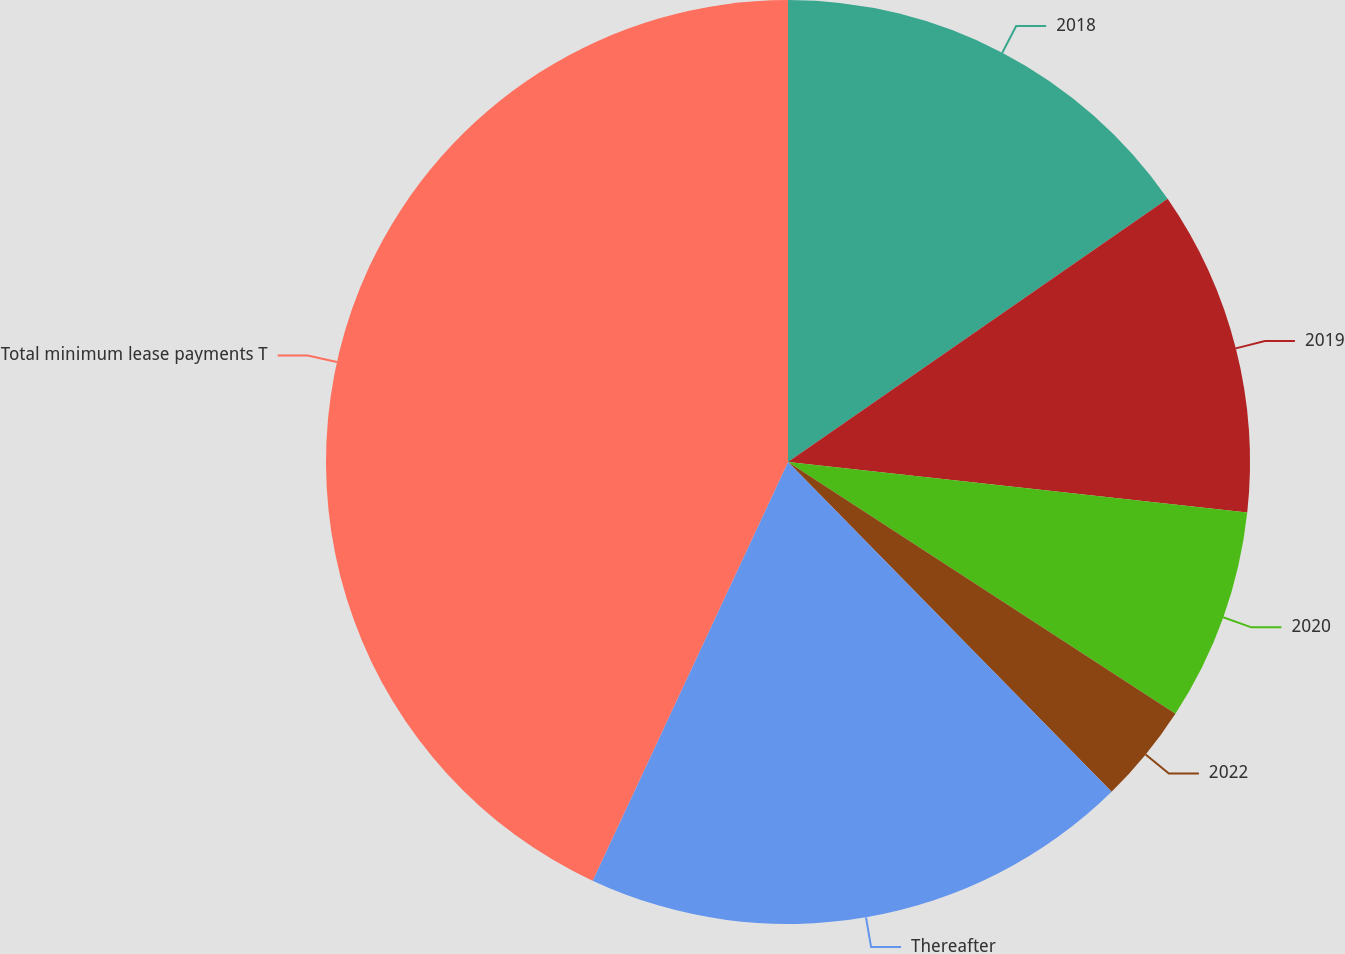<chart> <loc_0><loc_0><loc_500><loc_500><pie_chart><fcel>2018<fcel>2019<fcel>2020<fcel>2022<fcel>Thereafter<fcel>Total minimum lease payments T<nl><fcel>15.35%<fcel>11.39%<fcel>7.43%<fcel>3.48%<fcel>19.3%<fcel>43.05%<nl></chart> 